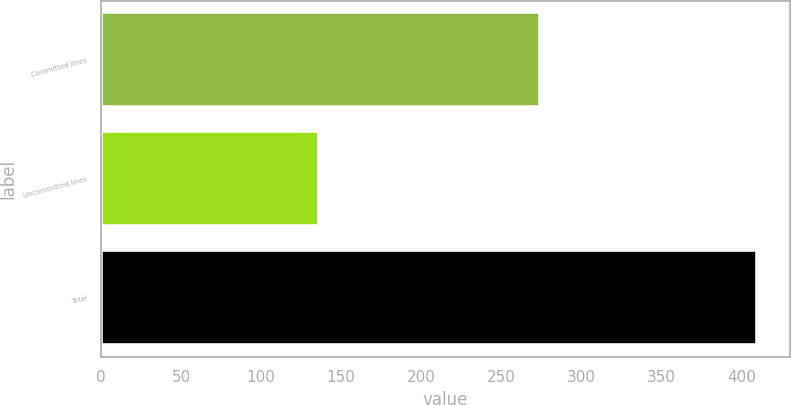Convert chart to OTSL. <chart><loc_0><loc_0><loc_500><loc_500><bar_chart><fcel>Committed lines<fcel>Uncommitted lines<fcel>Total<nl><fcel>274<fcel>136<fcel>410<nl></chart> 